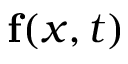Convert formula to latex. <formula><loc_0><loc_0><loc_500><loc_500>f ( x , t )</formula> 